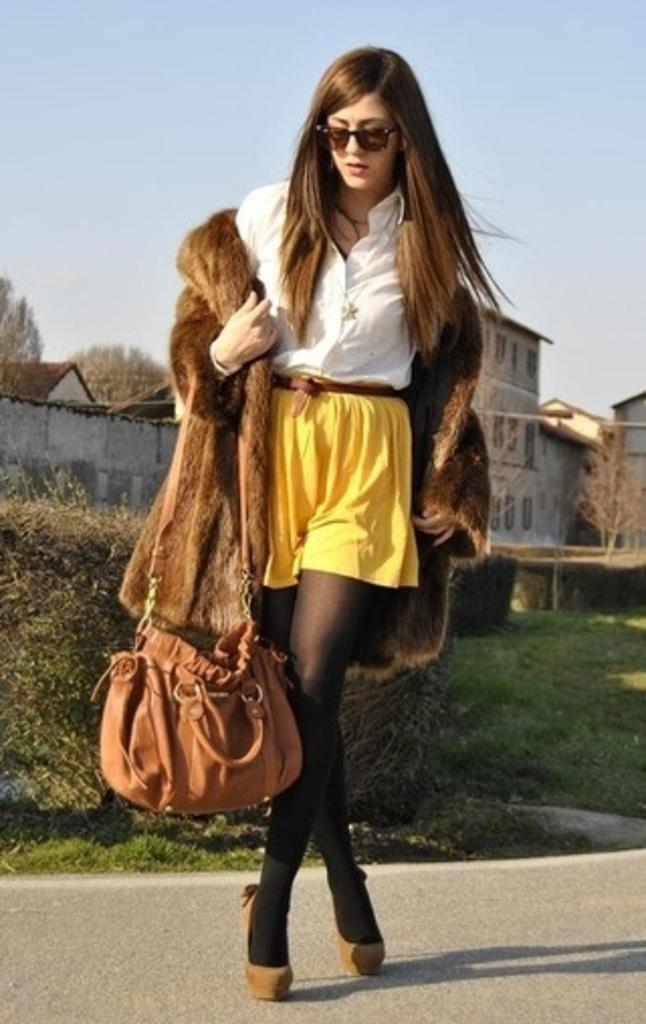Who or what is present in the image? There is a person in the image. What is the person wearing? The person is wearing a bag. What can be seen in the background of the image? There are trees, a building, and the sky visible in the background of the image. What type of instrument is the person playing in the image? There is no instrument present in the image; the person is simply wearing a bag. Can you see a playground in the image? There is no playground visible in the image; it features a person, trees, a building, and the sky. 